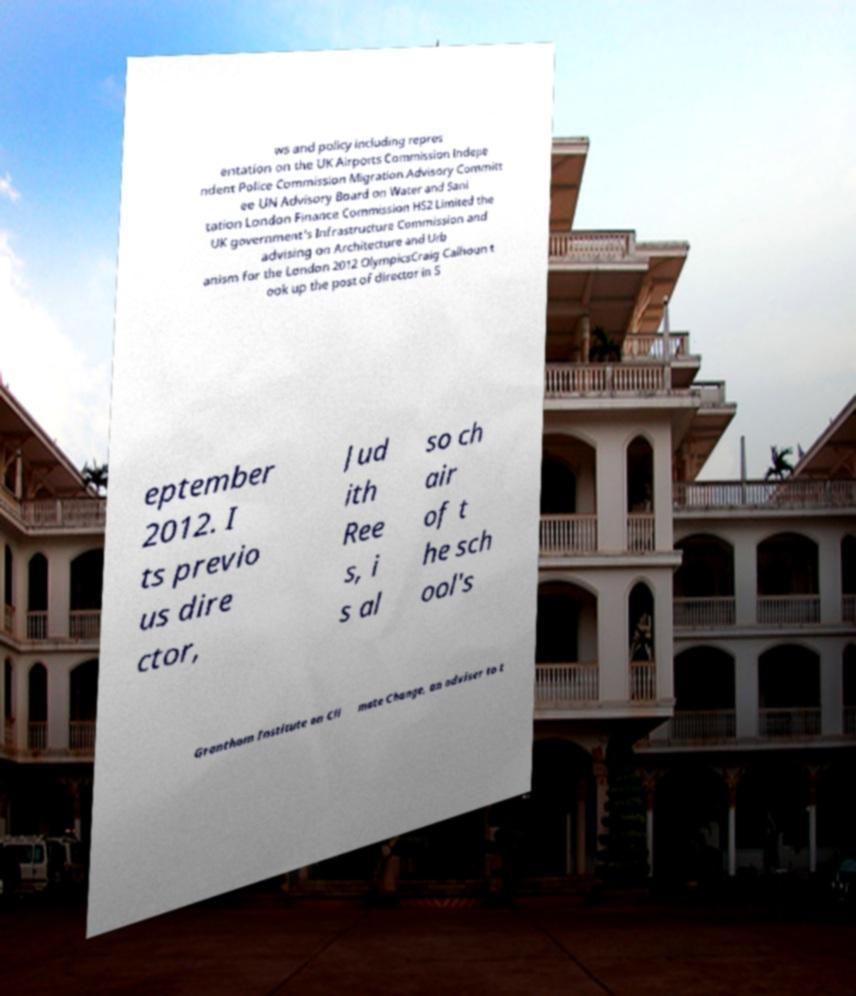Please read and relay the text visible in this image. What does it say? ws and policy including repres entation on the UK Airports Commission Indepe ndent Police Commission Migration Advisory Committ ee UN Advisory Board on Water and Sani tation London Finance Commission HS2 Limited the UK government's Infrastructure Commission and advising on Architecture and Urb anism for the London 2012 OlympicsCraig Calhoun t ook up the post of director in S eptember 2012. I ts previo us dire ctor, Jud ith Ree s, i s al so ch air of t he sch ool's Grantham Institute on Cli mate Change, an adviser to t 